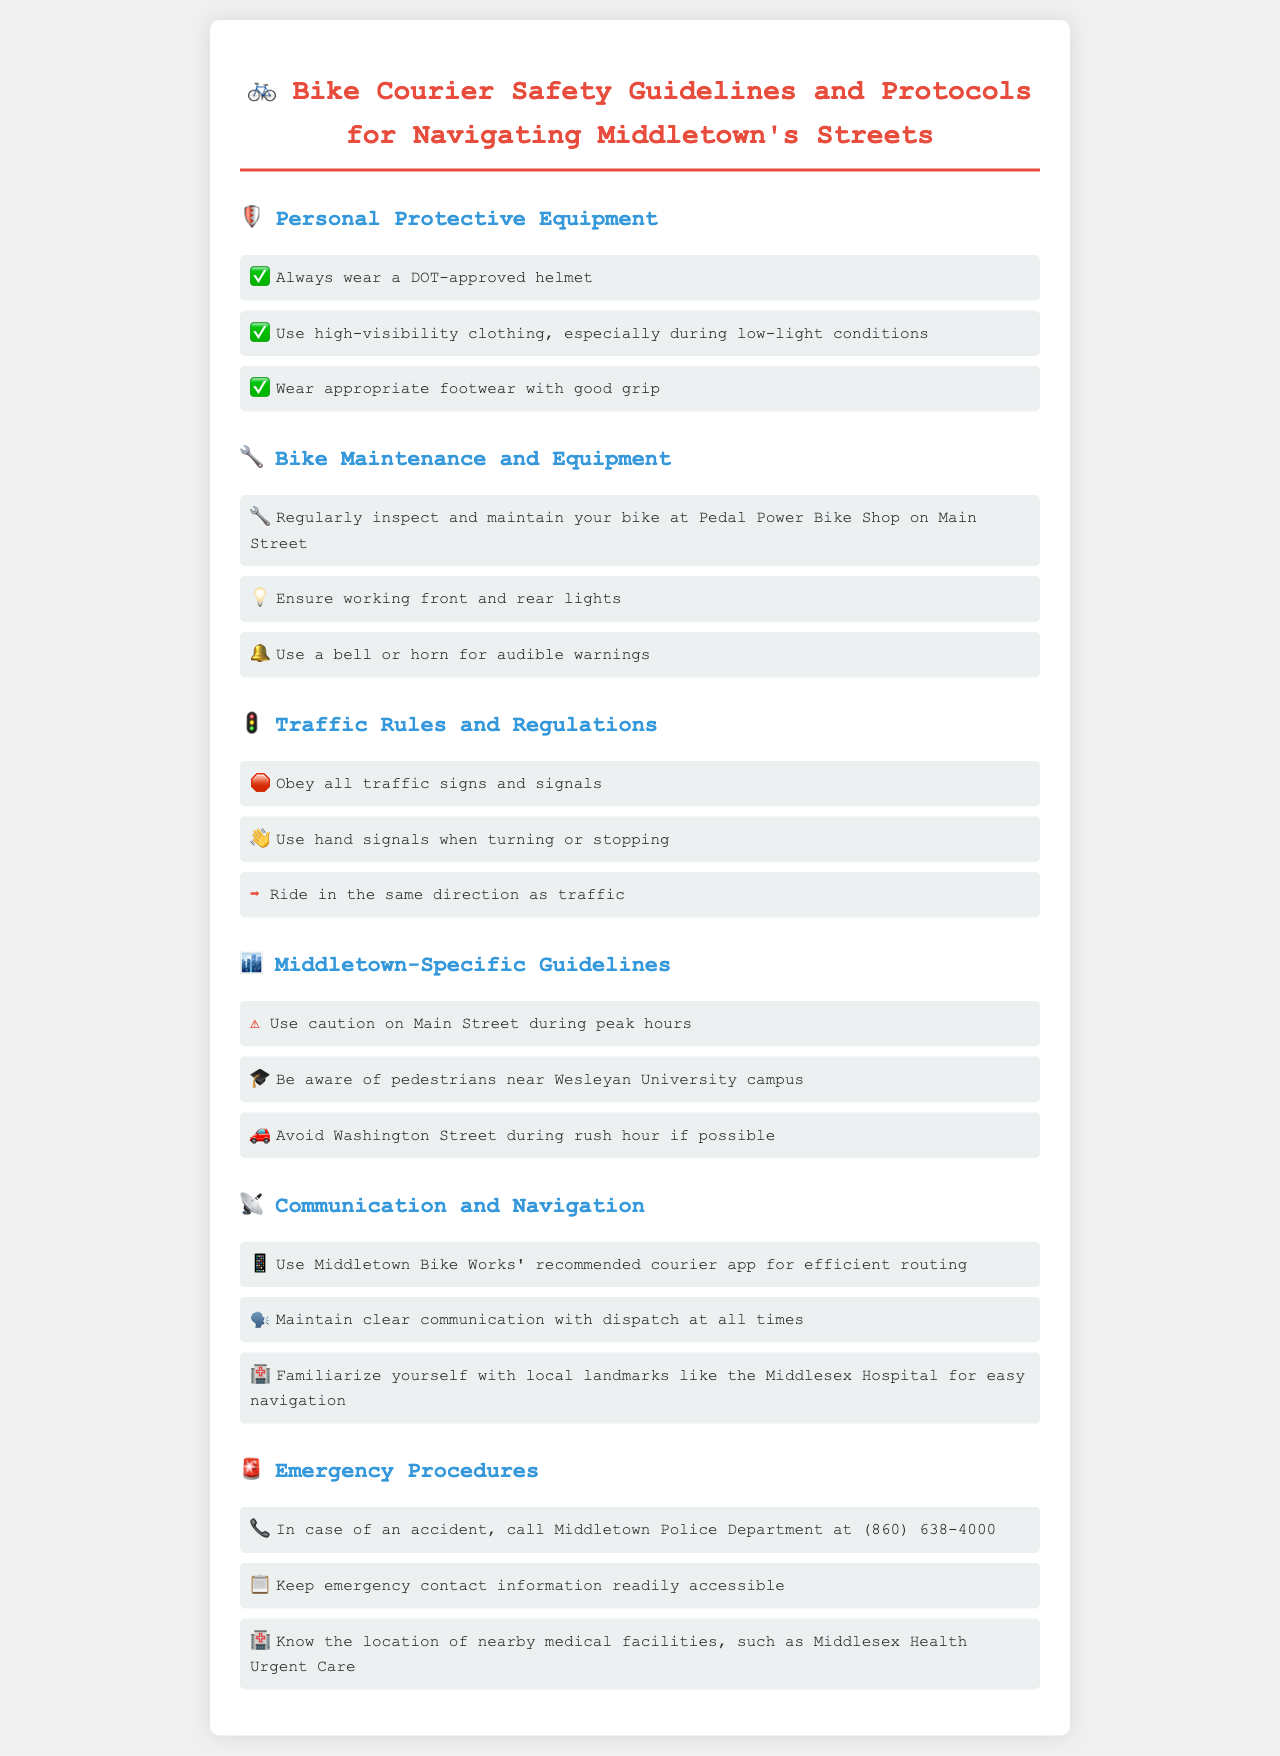What type of helmet should I wear? The document specifies that a DOT-approved helmet should be worn for safety.
Answer: DOT-approved helmet What is the recommended shop for bike maintenance? The document states that regular inspections should be done at Pedal Power Bike Shop on Main Street.
Answer: Pedal Power Bike Shop What should you use to signal when turning? It is stated that hand signals should be used when turning or stopping.
Answer: Hand signals What area requires caution during peak hours? The document mentions Main Street as an area that requires caution during peak hours.
Answer: Main Street Which app is recommended for efficient routing? Middletown Bike Works' recommended courier app is suggested for efficient navigation.
Answer: courier app How should riders ride in relation to traffic? The guidelines indicate that riders should ride in the same direction as traffic.
Answer: Same direction as traffic What should you do in case of an accident? The document instructs to call Middletown Police Department at (860) 638-4000 in case of an accident.
Answer: (860) 638-4000 What color clothing should couriers wear during low-light conditions? High-visibility clothing is recommended to be worn during low-light conditions.
Answer: High-visibility clothing What type of footwear is suggested? The document advises wearing appropriate footwear with good grip.
Answer: Good grip footwear 